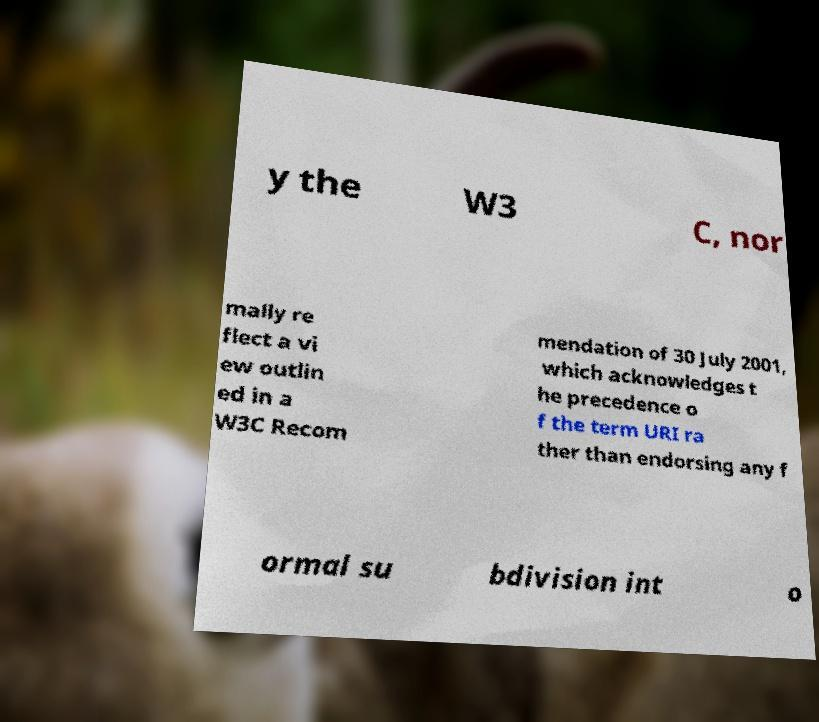For documentation purposes, I need the text within this image transcribed. Could you provide that? y the W3 C, nor mally re flect a vi ew outlin ed in a W3C Recom mendation of 30 July 2001, which acknowledges t he precedence o f the term URI ra ther than endorsing any f ormal su bdivision int o 